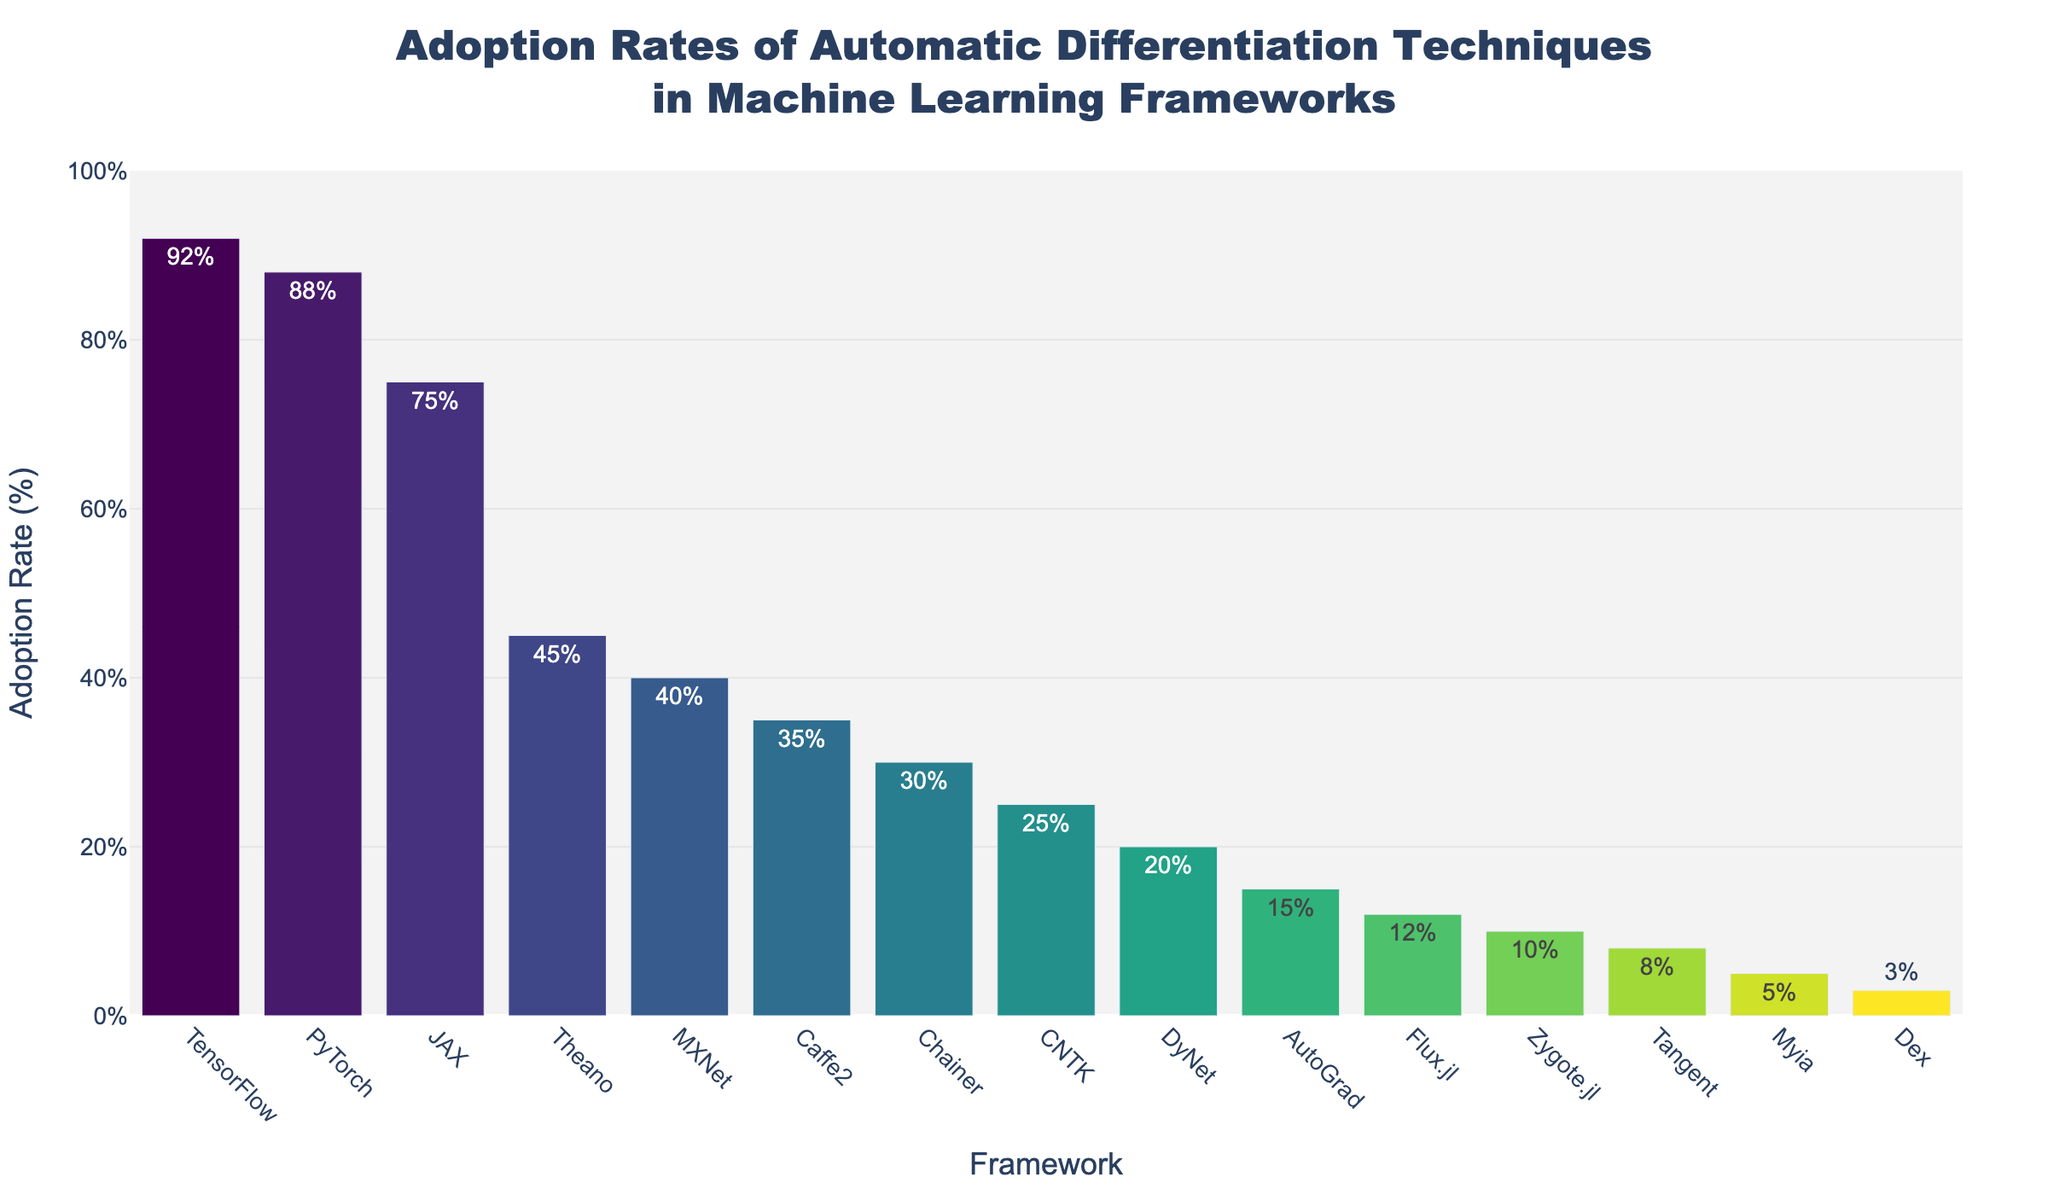Which framework has the highest adoption rate? By visually inspecting the height of the bars, the bar representing TensorFlow is the tallest, indicating it has the highest adoption rate of 92%.
Answer: TensorFlow Which two frameworks have equal or nearly equal adoption rates? By comparing the heights of all the bars, TensorFlow and PyTorch have similar heights indicating close adoption rates, with TensorFlow at 92% and PyTorch at 88%.
Answer: TensorFlow and PyTorch What is the range of adoption rates displayed in the chart? The minimum adoption rate is shown for Dex at 3%, and the maximum is for TensorFlow at 92%. The range is calculated as 92% - 3% = 89%.
Answer: 89% Which framework has a higher adoption rate: Theano or MXNet? By comparing the bars for Theano and MXNet, Theano's bar is higher at 45%, while MXNet's is lower at 40%.
Answer: Theano What is the average adoption rate of the top 3 frameworks? The top 3 frameworks are TensorFlow (92%), PyTorch (88%), and JAX (75%). The average adoption rate is calculated as (92 + 88 + 75) / 3 = 85%.
Answer: 85% What is the median adoption rate of all the frameworks? To find the median, the frameworks must be listed in numerical order of their adoption rates: 3, 5, 8, 10, 12, 15, 20, 25, 30, 35, 40, 45, 75, 88, 92. The median value, being the middle value in the ordered list, is 25%.
Answer: 25% Which framework has the lowest adoption rate among the ones listed? The shortest bar represents Dex, which is the framework with the lowest adoption rate at 3%.
Answer: Dex If the adoption rates of Theano and CNTK are combined, what would be their total? Adding the adoption rates of Theano (45%) and CNTK (25%) results in a combined rate of 45% + 25% = 70%.
Answer: 70% What percentage difference is there between the adoption rates of AutoGrad and Zygote.jl? AutoGrad has an adoption rate of 15%, and Zygote.jl has 10%. The difference is calculated as 15% - 10% = 5%.
Answer: 5% How many frameworks have an adoption rate below 50%? Counting the bars representing frameworks with adoption rates below 50%, there are 11 frameworks: Theano, MXNet, Caffe2, Chainer, CNTK, DyNet, AutoGrad, Flux.jl, Zygote.jl, Tangent, Myia, and Dex.
Answer: 11 